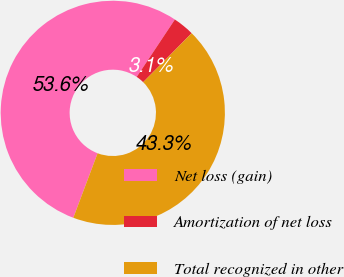Convert chart to OTSL. <chart><loc_0><loc_0><loc_500><loc_500><pie_chart><fcel>Net loss (gain)<fcel>Amortization of net loss<fcel>Total recognized in other<nl><fcel>53.61%<fcel>3.09%<fcel>43.3%<nl></chart> 